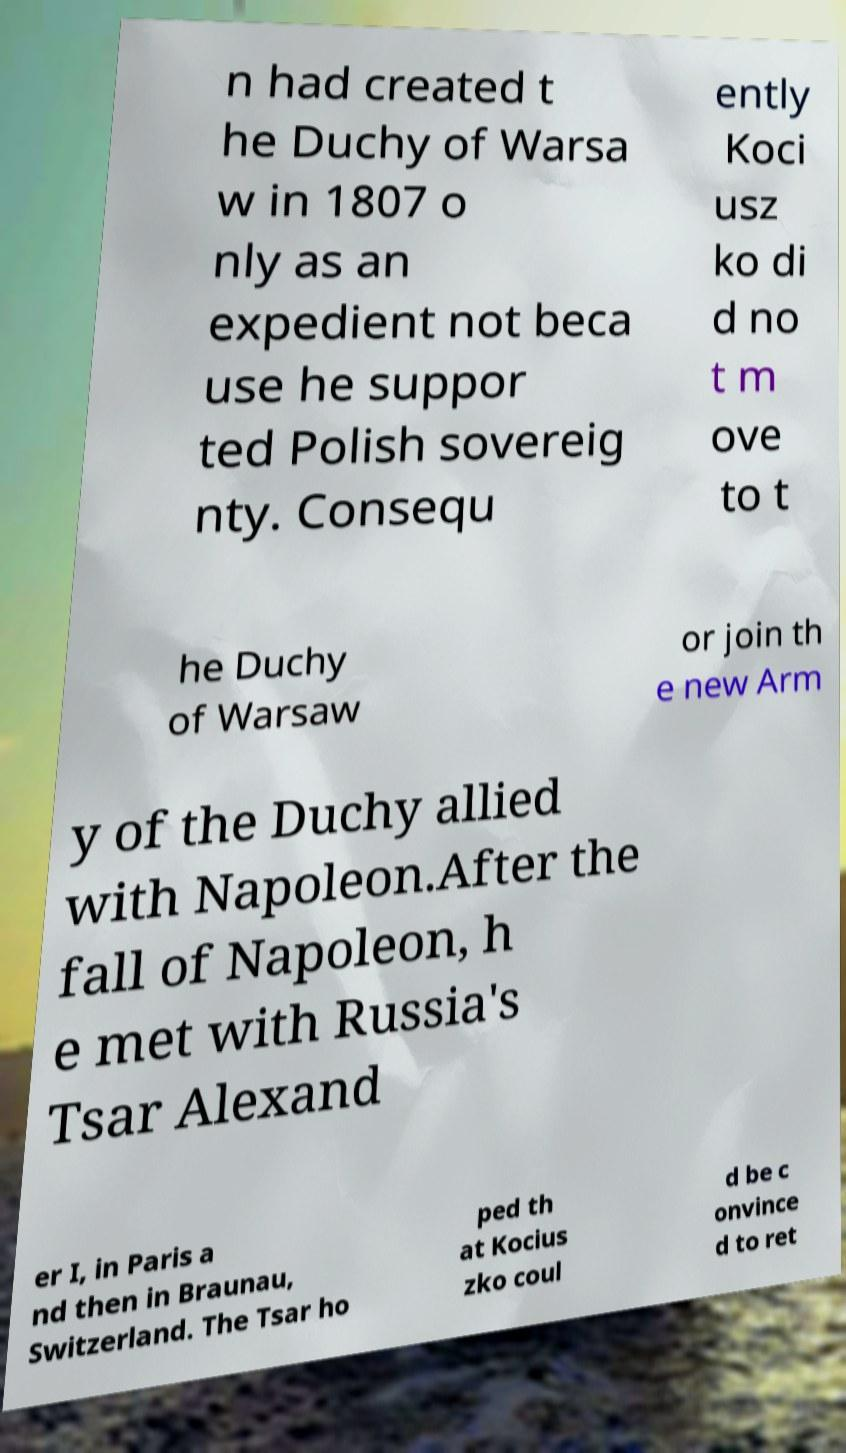What messages or text are displayed in this image? I need them in a readable, typed format. n had created t he Duchy of Warsa w in 1807 o nly as an expedient not beca use he suppor ted Polish sovereig nty. Consequ ently Koci usz ko di d no t m ove to t he Duchy of Warsaw or join th e new Arm y of the Duchy allied with Napoleon.After the fall of Napoleon, h e met with Russia's Tsar Alexand er I, in Paris a nd then in Braunau, Switzerland. The Tsar ho ped th at Kocius zko coul d be c onvince d to ret 